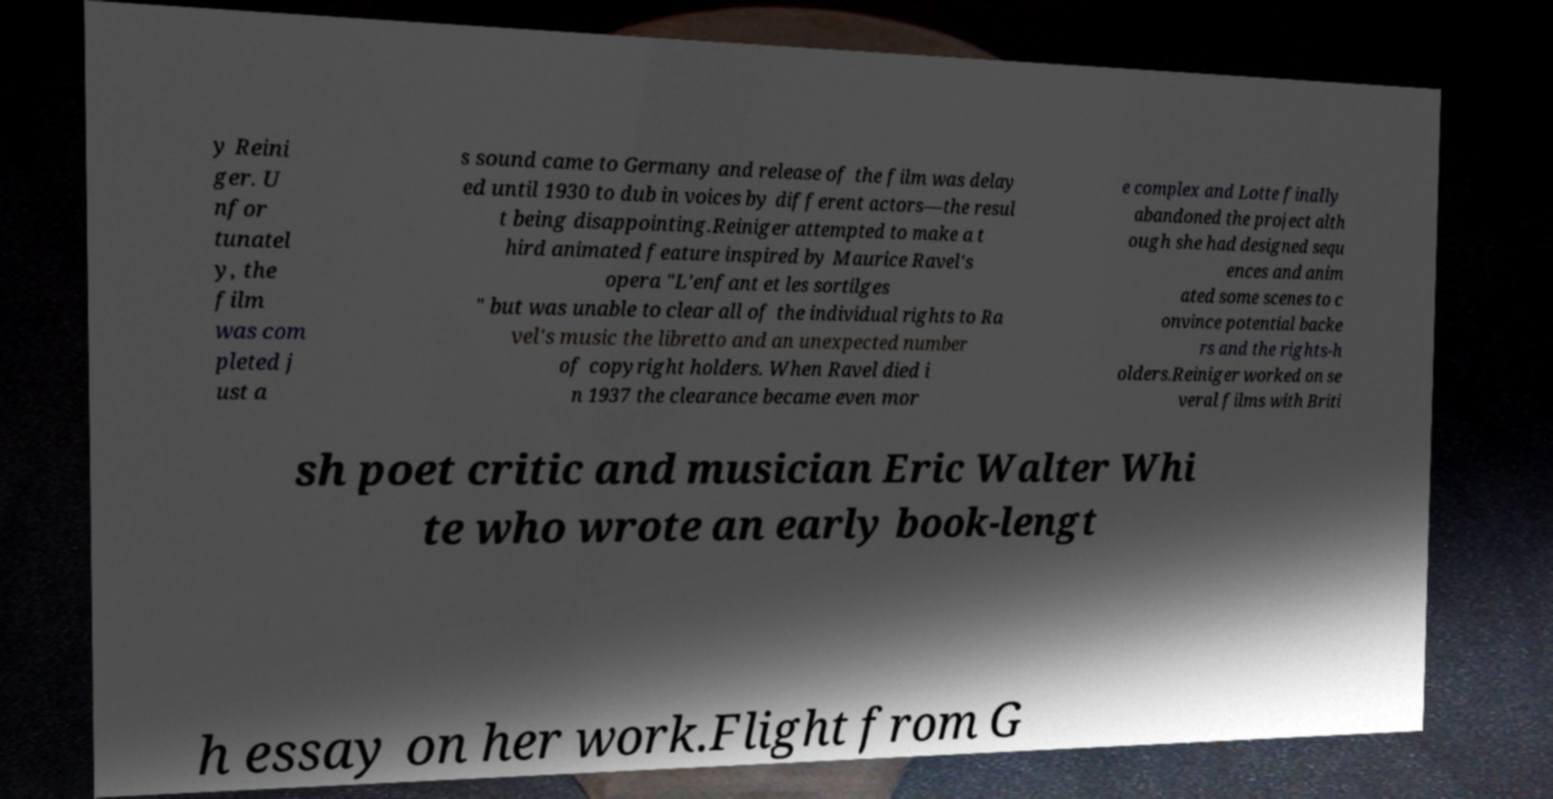Could you extract and type out the text from this image? y Reini ger. U nfor tunatel y, the film was com pleted j ust a s sound came to Germany and release of the film was delay ed until 1930 to dub in voices by different actors—the resul t being disappointing.Reiniger attempted to make a t hird animated feature inspired by Maurice Ravel's opera "L'enfant et les sortilges " but was unable to clear all of the individual rights to Ra vel's music the libretto and an unexpected number of copyright holders. When Ravel died i n 1937 the clearance became even mor e complex and Lotte finally abandoned the project alth ough she had designed sequ ences and anim ated some scenes to c onvince potential backe rs and the rights-h olders.Reiniger worked on se veral films with Briti sh poet critic and musician Eric Walter Whi te who wrote an early book-lengt h essay on her work.Flight from G 